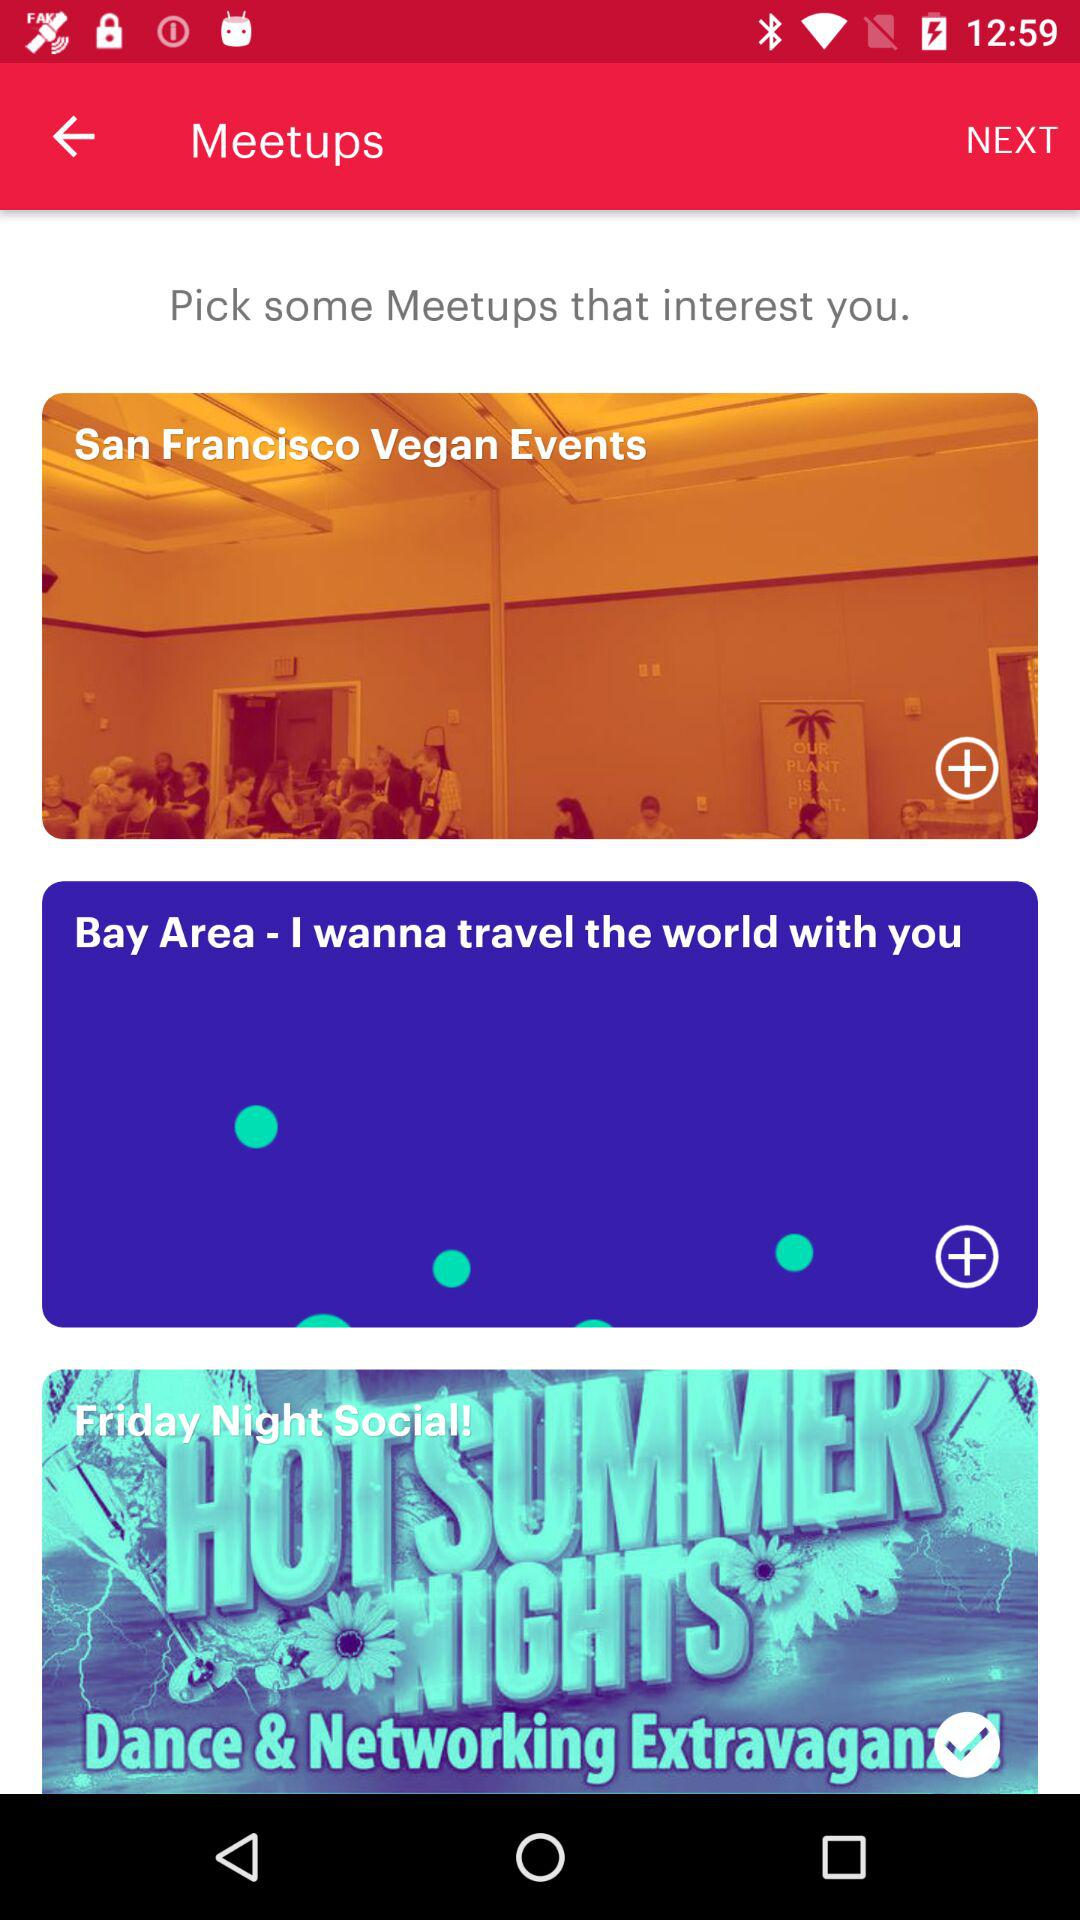What are the different meetup events? The different meetup events are "San Francisco Vegan Events", "Bay Area - I wanna travel the world with you" and "Friday Night Social!". 